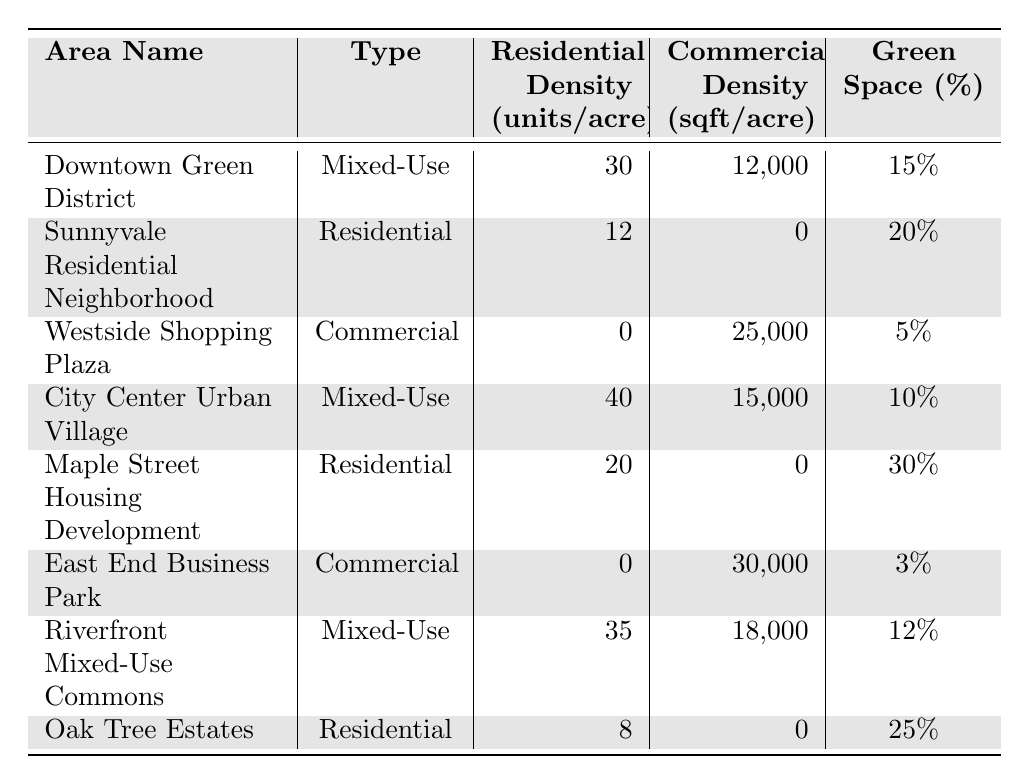What is the residential density per acre in the City Center Urban Village? The residential density for the City Center Urban Village is listed in the table next to its name, which shows a value of 40 units per acre.
Answer: 40 What is the commercial density per acre in the Westside Shopping Plaza? The table states the commercial density for the Westside Shopping Plaza as 25,000 square feet per acre, which is directly referenced next to the area name.
Answer: 25,000 Which area has the highest green space percentage? By reviewing the green space percentages across all areas listed in the table, Maple Street Housing Development has the highest percentage at 30%.
Answer: Maple Street Housing Development Is there any residential area that has a commercial density? The table shows that all residential areas have a commercial density of 0, meaning there are no commercial activities permitted in these areas.
Answer: No What is the total residential density of all mixed-use areas combined? To find the total, we add the residential densities of all mixed-use areas: Downtown Green District (30) + City Center Urban Village (40) + Riverfront Mixed-Use Commons (35) = 105 units per acre.
Answer: 105 What is the average green space percentage for commercial areas? First, identify the green space percentages for the commercial areas: Westside Shopping Plaza (5%), East End Business Park (3%). Calculate the average: (5 + 3) / 2 = 4%.
Answer: 4% Which mixed-use area has a higher commercial density, Downtown Green District or Riverfront Mixed-Use Commons? The table shows Downtown Green District has a commercial density of 12,000 sq ft/acre, and Riverfront Mixed-Use Commons has 18,000 sq ft/acre, indicating that Riverfront Mixed-Use Commons has a higher commercial density.
Answer: Riverfront Mixed-Use Commons Is the residential density higher in Oak Tree Estates or Sunnyvale Residential Neighborhood? The table lists Oak Tree Estates with a residential density of 8 units per acre while Sunnyvale Residential Neighborhood has 12 units per acre, meaning Sunnyvale has higher residential density.
Answer: Sunnyvale Residential Neighborhood What percentage of green space do all mixed-use areas have combined? To find the combined percentage, we take Downtown Green District (15%), City Center Urban Village (10%), and Riverfront Mixed-Use Commons (12%). The total is 15 + 10 + 12 = 37%, and dividing by 3 to get the average gives 12.33%, which we round to 12%.
Answer: 12% How many residential units per acre are there in total across all residential areas? Adding the residential densities of all residential areas: Sunnyvale Residential Neighborhood (12) + Maple Street Housing Development (20) + Oak Tree Estates (8) = 40 units per acre in total.
Answer: 40 